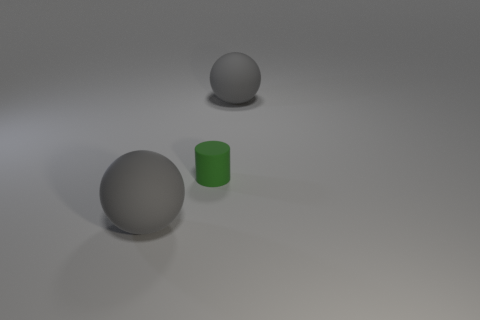Is the color of the large sphere that is to the right of the small green matte object the same as the small cylinder?
Your answer should be very brief. No. What is the shape of the large matte thing on the left side of the gray object that is to the right of the big gray object that is in front of the small green rubber cylinder?
Your answer should be very brief. Sphere. How many big gray objects are on the right side of the sphere that is behind the green rubber cylinder?
Your answer should be compact. 0. There is a big gray rubber object that is behind the rubber object in front of the tiny green cylinder; what number of rubber spheres are in front of it?
Offer a terse response. 1. What is the color of the large sphere that is in front of the tiny thing?
Give a very brief answer. Gray. The gray object in front of the large rubber thing that is on the right side of the rubber cylinder is what shape?
Give a very brief answer. Sphere. How many spheres are red things or big rubber objects?
Your answer should be compact. 2. What number of gray matte objects are behind the green object?
Provide a succinct answer. 1. Are the object that is in front of the small green rubber cylinder and the large gray thing behind the small rubber cylinder made of the same material?
Offer a terse response. Yes. How many things are big gray things that are left of the tiny cylinder or tiny yellow balls?
Your response must be concise. 1. 